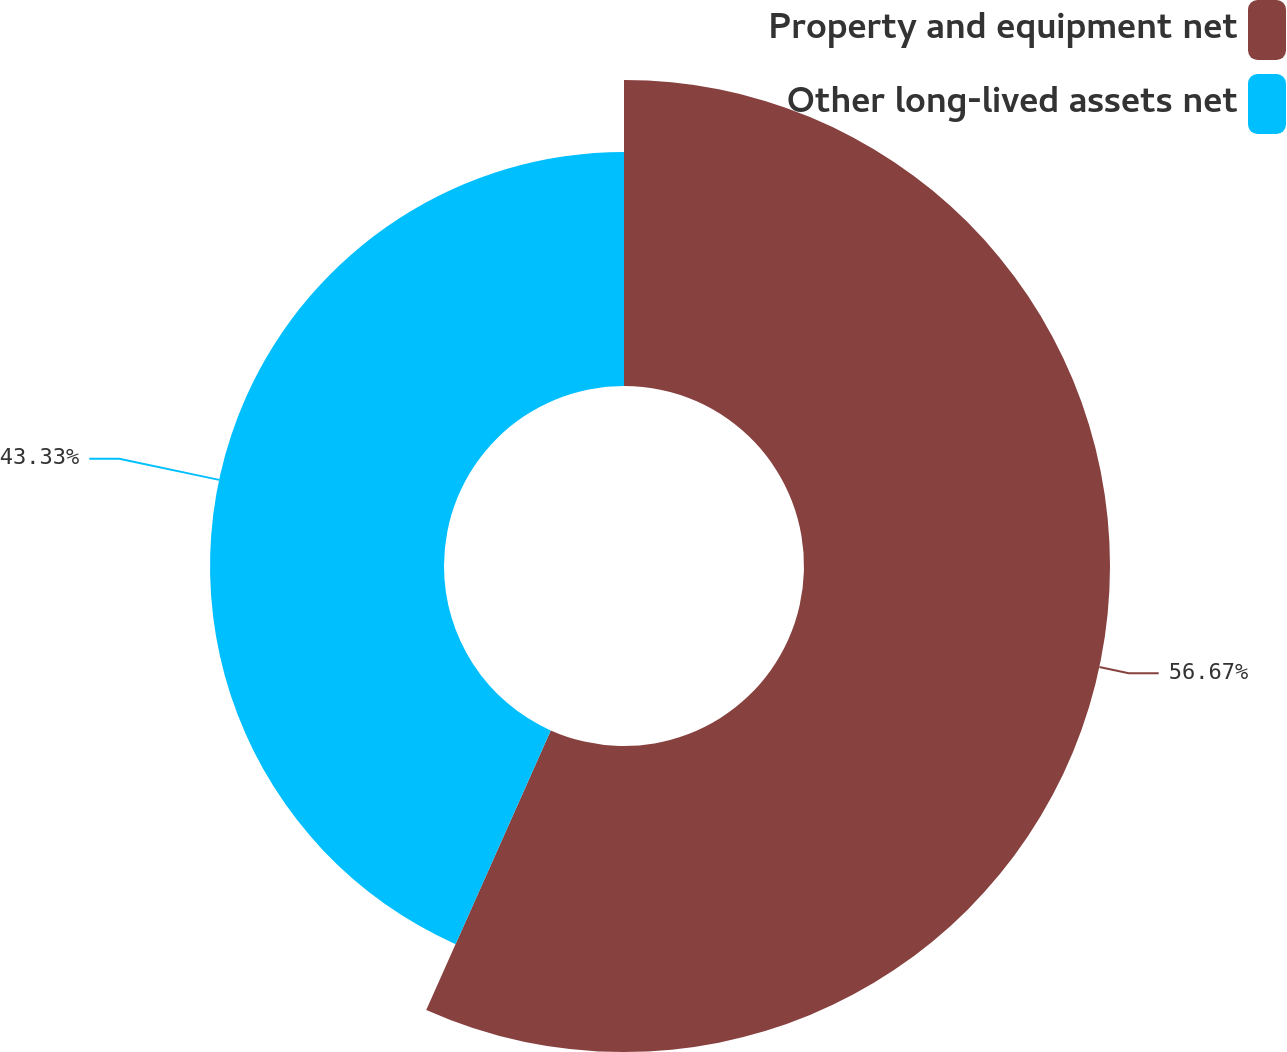Convert chart. <chart><loc_0><loc_0><loc_500><loc_500><pie_chart><fcel>Property and equipment net<fcel>Other long-lived assets net<nl><fcel>56.67%<fcel>43.33%<nl></chart> 